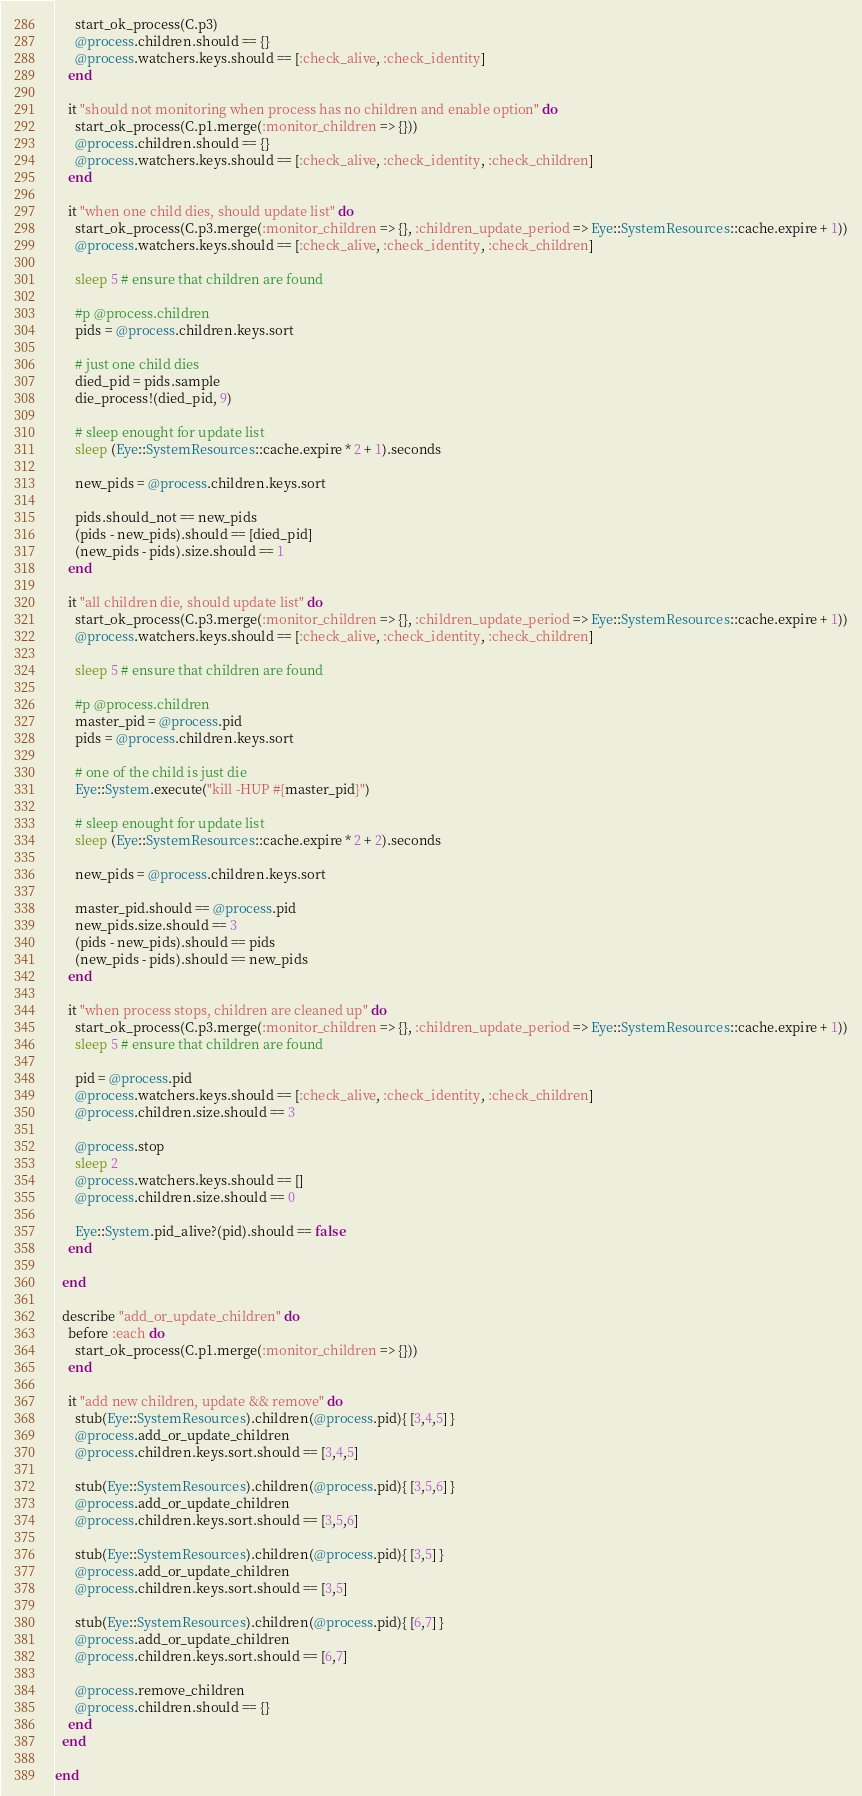<code> <loc_0><loc_0><loc_500><loc_500><_Ruby_>      start_ok_process(C.p3)
      @process.children.should == {}
      @process.watchers.keys.should == [:check_alive, :check_identity]
    end

    it "should not monitoring when process has no children and enable option" do
      start_ok_process(C.p1.merge(:monitor_children => {}))
      @process.children.should == {}
      @process.watchers.keys.should == [:check_alive, :check_identity, :check_children]
    end

    it "when one child dies, should update list" do
      start_ok_process(C.p3.merge(:monitor_children => {}, :children_update_period => Eye::SystemResources::cache.expire + 1))
      @process.watchers.keys.should == [:check_alive, :check_identity, :check_children]

      sleep 5 # ensure that children are found

      #p @process.children
      pids = @process.children.keys.sort

      # just one child dies
      died_pid = pids.sample
      die_process!(died_pid, 9)

      # sleep enought for update list
      sleep (Eye::SystemResources::cache.expire * 2 + 1).seconds

      new_pids = @process.children.keys.sort

      pids.should_not == new_pids
      (pids - new_pids).should == [died_pid]
      (new_pids - pids).size.should == 1
    end

    it "all children die, should update list" do
      start_ok_process(C.p3.merge(:monitor_children => {}, :children_update_period => Eye::SystemResources::cache.expire + 1))
      @process.watchers.keys.should == [:check_alive, :check_identity, :check_children]

      sleep 5 # ensure that children are found

      #p @process.children
      master_pid = @process.pid
      pids = @process.children.keys.sort

      # one of the child is just die
      Eye::System.execute("kill -HUP #{master_pid}")

      # sleep enought for update list
      sleep (Eye::SystemResources::cache.expire * 2 + 2).seconds

      new_pids = @process.children.keys.sort

      master_pid.should == @process.pid
      new_pids.size.should == 3
      (pids - new_pids).should == pids
      (new_pids - pids).should == new_pids
    end

    it "when process stops, children are cleaned up" do
      start_ok_process(C.p3.merge(:monitor_children => {}, :children_update_period => Eye::SystemResources::cache.expire + 1))
      sleep 5 # ensure that children are found

      pid = @process.pid
      @process.watchers.keys.should == [:check_alive, :check_identity, :check_children]
      @process.children.size.should == 3

      @process.stop
      sleep 2
      @process.watchers.keys.should == []
      @process.children.size.should == 0

      Eye::System.pid_alive?(pid).should == false
    end

  end

  describe "add_or_update_children" do
    before :each do
      start_ok_process(C.p1.merge(:monitor_children => {}))
    end

    it "add new children, update && remove" do
      stub(Eye::SystemResources).children(@process.pid){ [3,4,5] }
      @process.add_or_update_children
      @process.children.keys.sort.should == [3,4,5]

      stub(Eye::SystemResources).children(@process.pid){ [3,5,6] }
      @process.add_or_update_children
      @process.children.keys.sort.should == [3,5,6]

      stub(Eye::SystemResources).children(@process.pid){ [3,5] }
      @process.add_or_update_children
      @process.children.keys.sort.should == [3,5]

      stub(Eye::SystemResources).children(@process.pid){ [6,7] }
      @process.add_or_update_children
      @process.children.keys.sort.should == [6,7]

      @process.remove_children
      @process.children.should == {}
    end
  end

end
</code> 